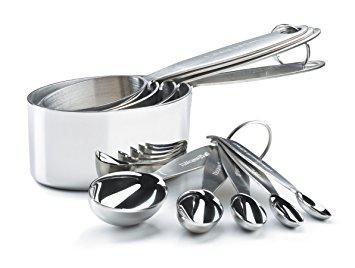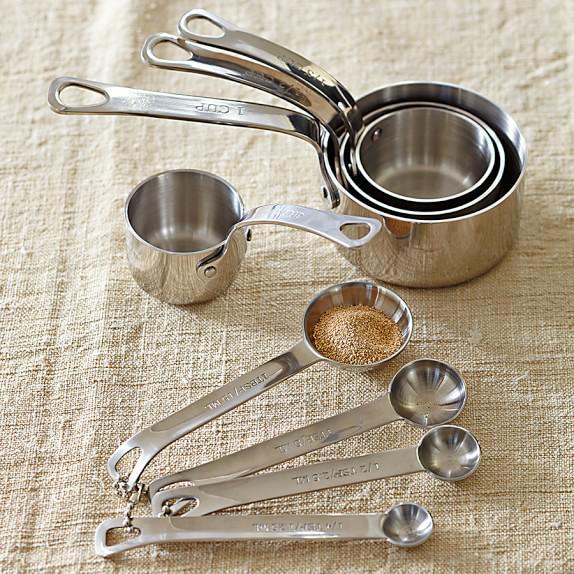The first image is the image on the left, the second image is the image on the right. Considering the images on both sides, is "There is at least clear measuring cup in one of the images." valid? Answer yes or no. No. 